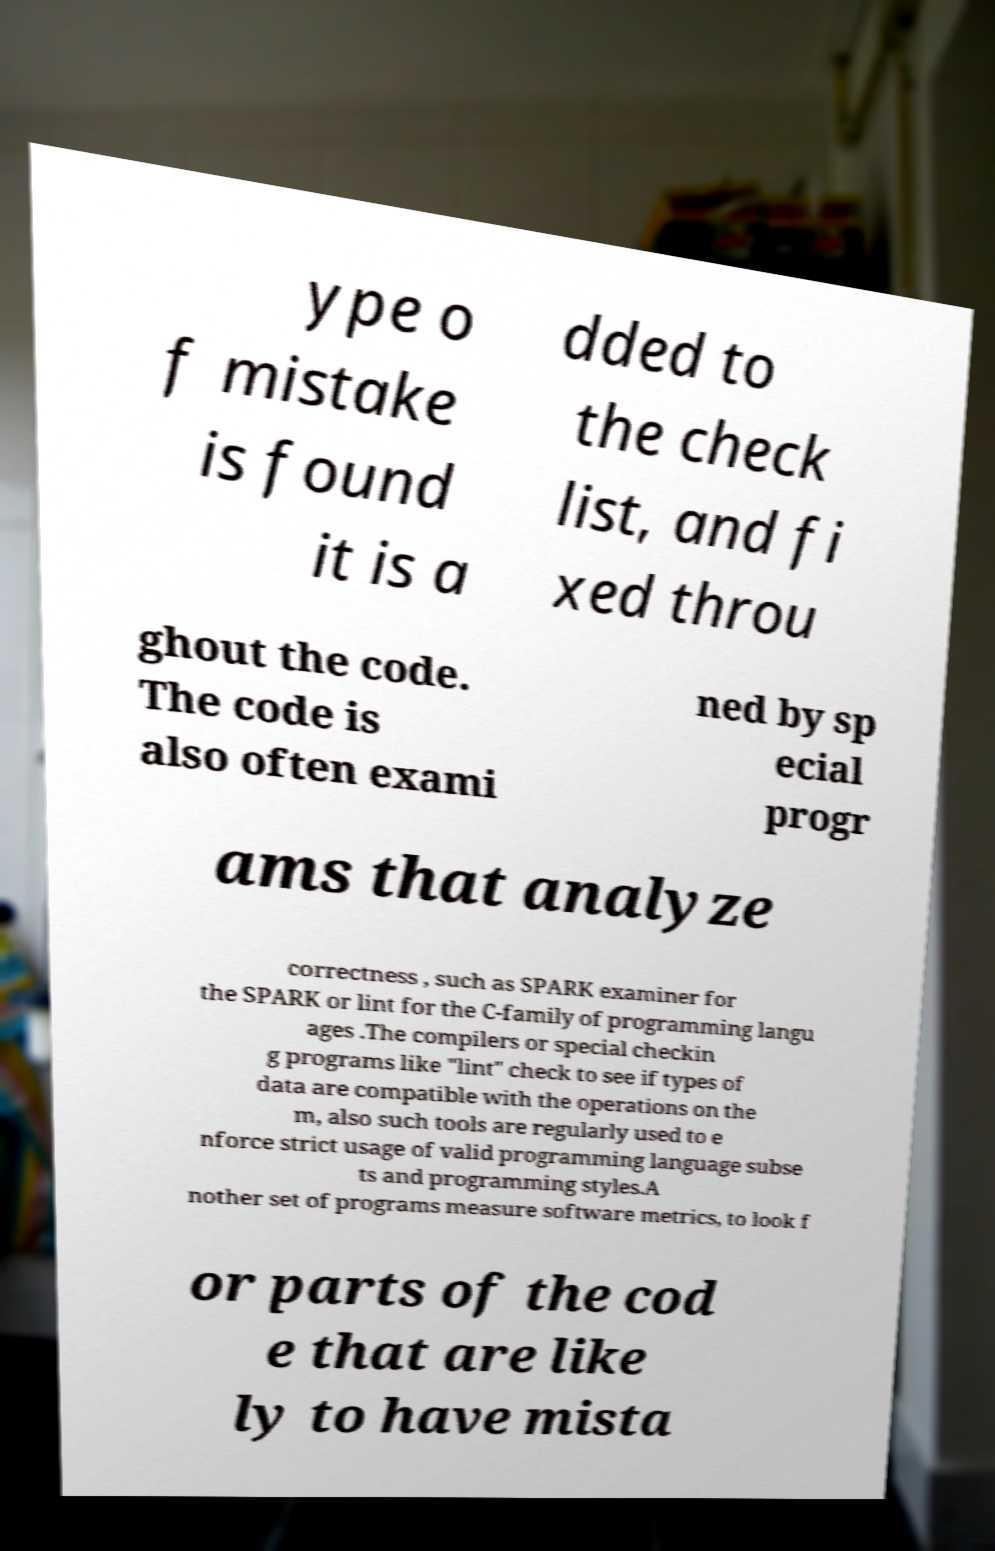Please read and relay the text visible in this image. What does it say? ype o f mistake is found it is a dded to the check list, and fi xed throu ghout the code. The code is also often exami ned by sp ecial progr ams that analyze correctness , such as SPARK examiner for the SPARK or lint for the C-family of programming langu ages .The compilers or special checkin g programs like "lint" check to see if types of data are compatible with the operations on the m, also such tools are regularly used to e nforce strict usage of valid programming language subse ts and programming styles.A nother set of programs measure software metrics, to look f or parts of the cod e that are like ly to have mista 